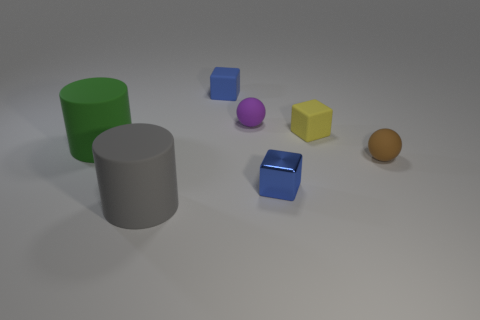Are there any small objects that have the same material as the large green cylinder?
Make the answer very short. Yes. There is a blue cube in front of the big green rubber object; what is its material?
Make the answer very short. Metal. What material is the big gray cylinder?
Give a very brief answer. Rubber. Do the gray object in front of the tiny blue rubber thing and the tiny purple ball have the same material?
Offer a terse response. Yes. Are there fewer gray cylinders in front of the blue matte cube than yellow matte cubes?
Your answer should be compact. No. What color is the metal object that is the same size as the brown rubber thing?
Offer a terse response. Blue. What number of brown things have the same shape as the small purple matte object?
Offer a terse response. 1. The matte cylinder that is in front of the tiny metallic cube is what color?
Your response must be concise. Gray. What number of matte things are large purple spheres or cylinders?
Ensure brevity in your answer.  2. What shape is the small matte thing that is the same color as the metal thing?
Keep it short and to the point. Cube. 